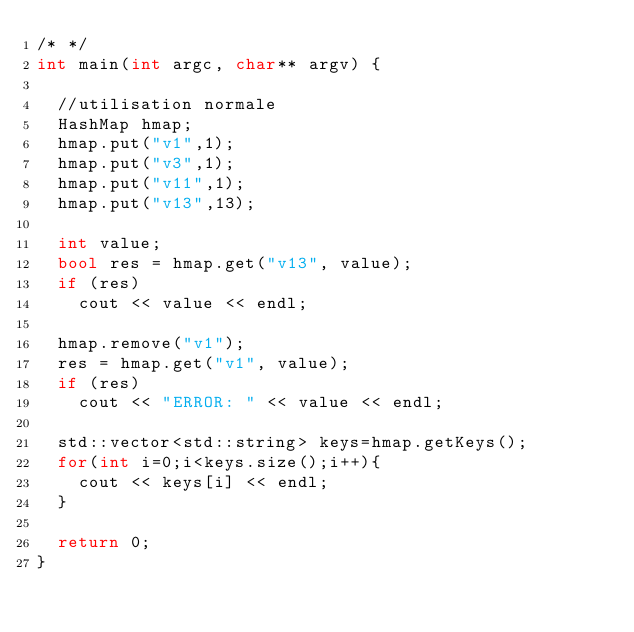Convert code to text. <code><loc_0><loc_0><loc_500><loc_500><_C++_>/* */
int main(int argc, char** argv) {

  //utilisation normale
  HashMap hmap;
  hmap.put("v1",1);
  hmap.put("v3",1);
  hmap.put("v11",1);
  hmap.put("v13",13);
  
  int value;
  bool res = hmap.get("v13", value);
  if (res)
    cout << value << endl;
  
  hmap.remove("v1");
  res = hmap.get("v1", value);
  if (res)
    cout << "ERROR: " << value << endl;

  std::vector<std::string> keys=hmap.getKeys();
  for(int i=0;i<keys.size();i++){
    cout << keys[i] << endl;
  }
  
  return 0;
}

</code> 